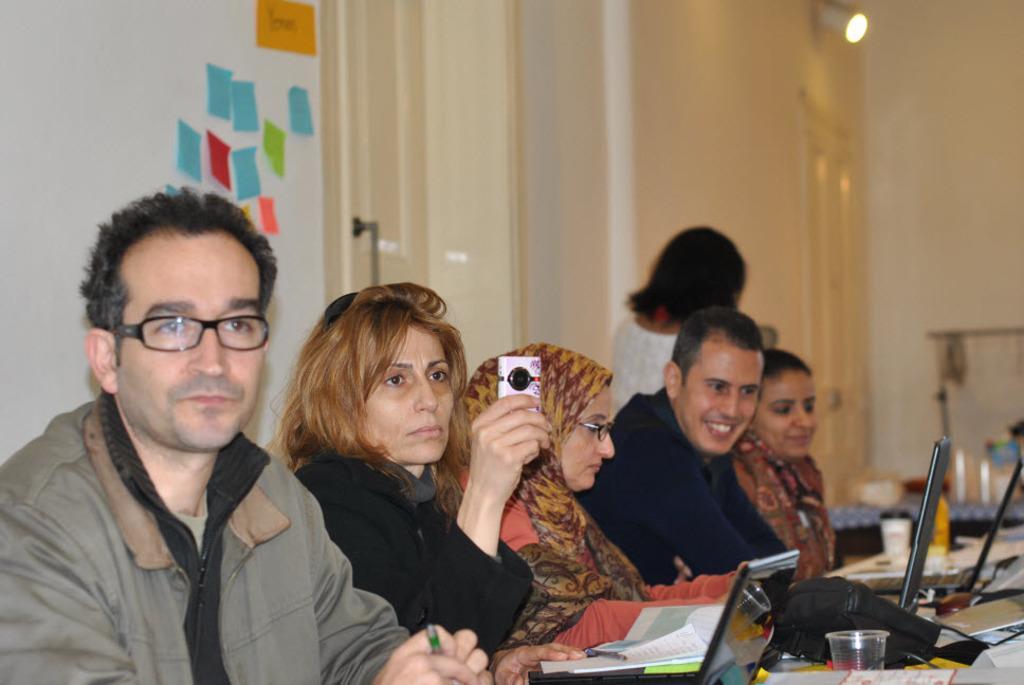Describe this image in one or two sentences. This is the picture of a room. In this image there are group of people sitting. There are laptops, papers and there is a bottle, glass, bag on the table. At the back there is a person standing and there are objects on the table and there are doors and there are papers on the wall. At the top there is a light. 